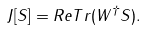<formula> <loc_0><loc_0><loc_500><loc_500>J [ S ] = R e T r ( W ^ { \dagger } S ) .</formula> 